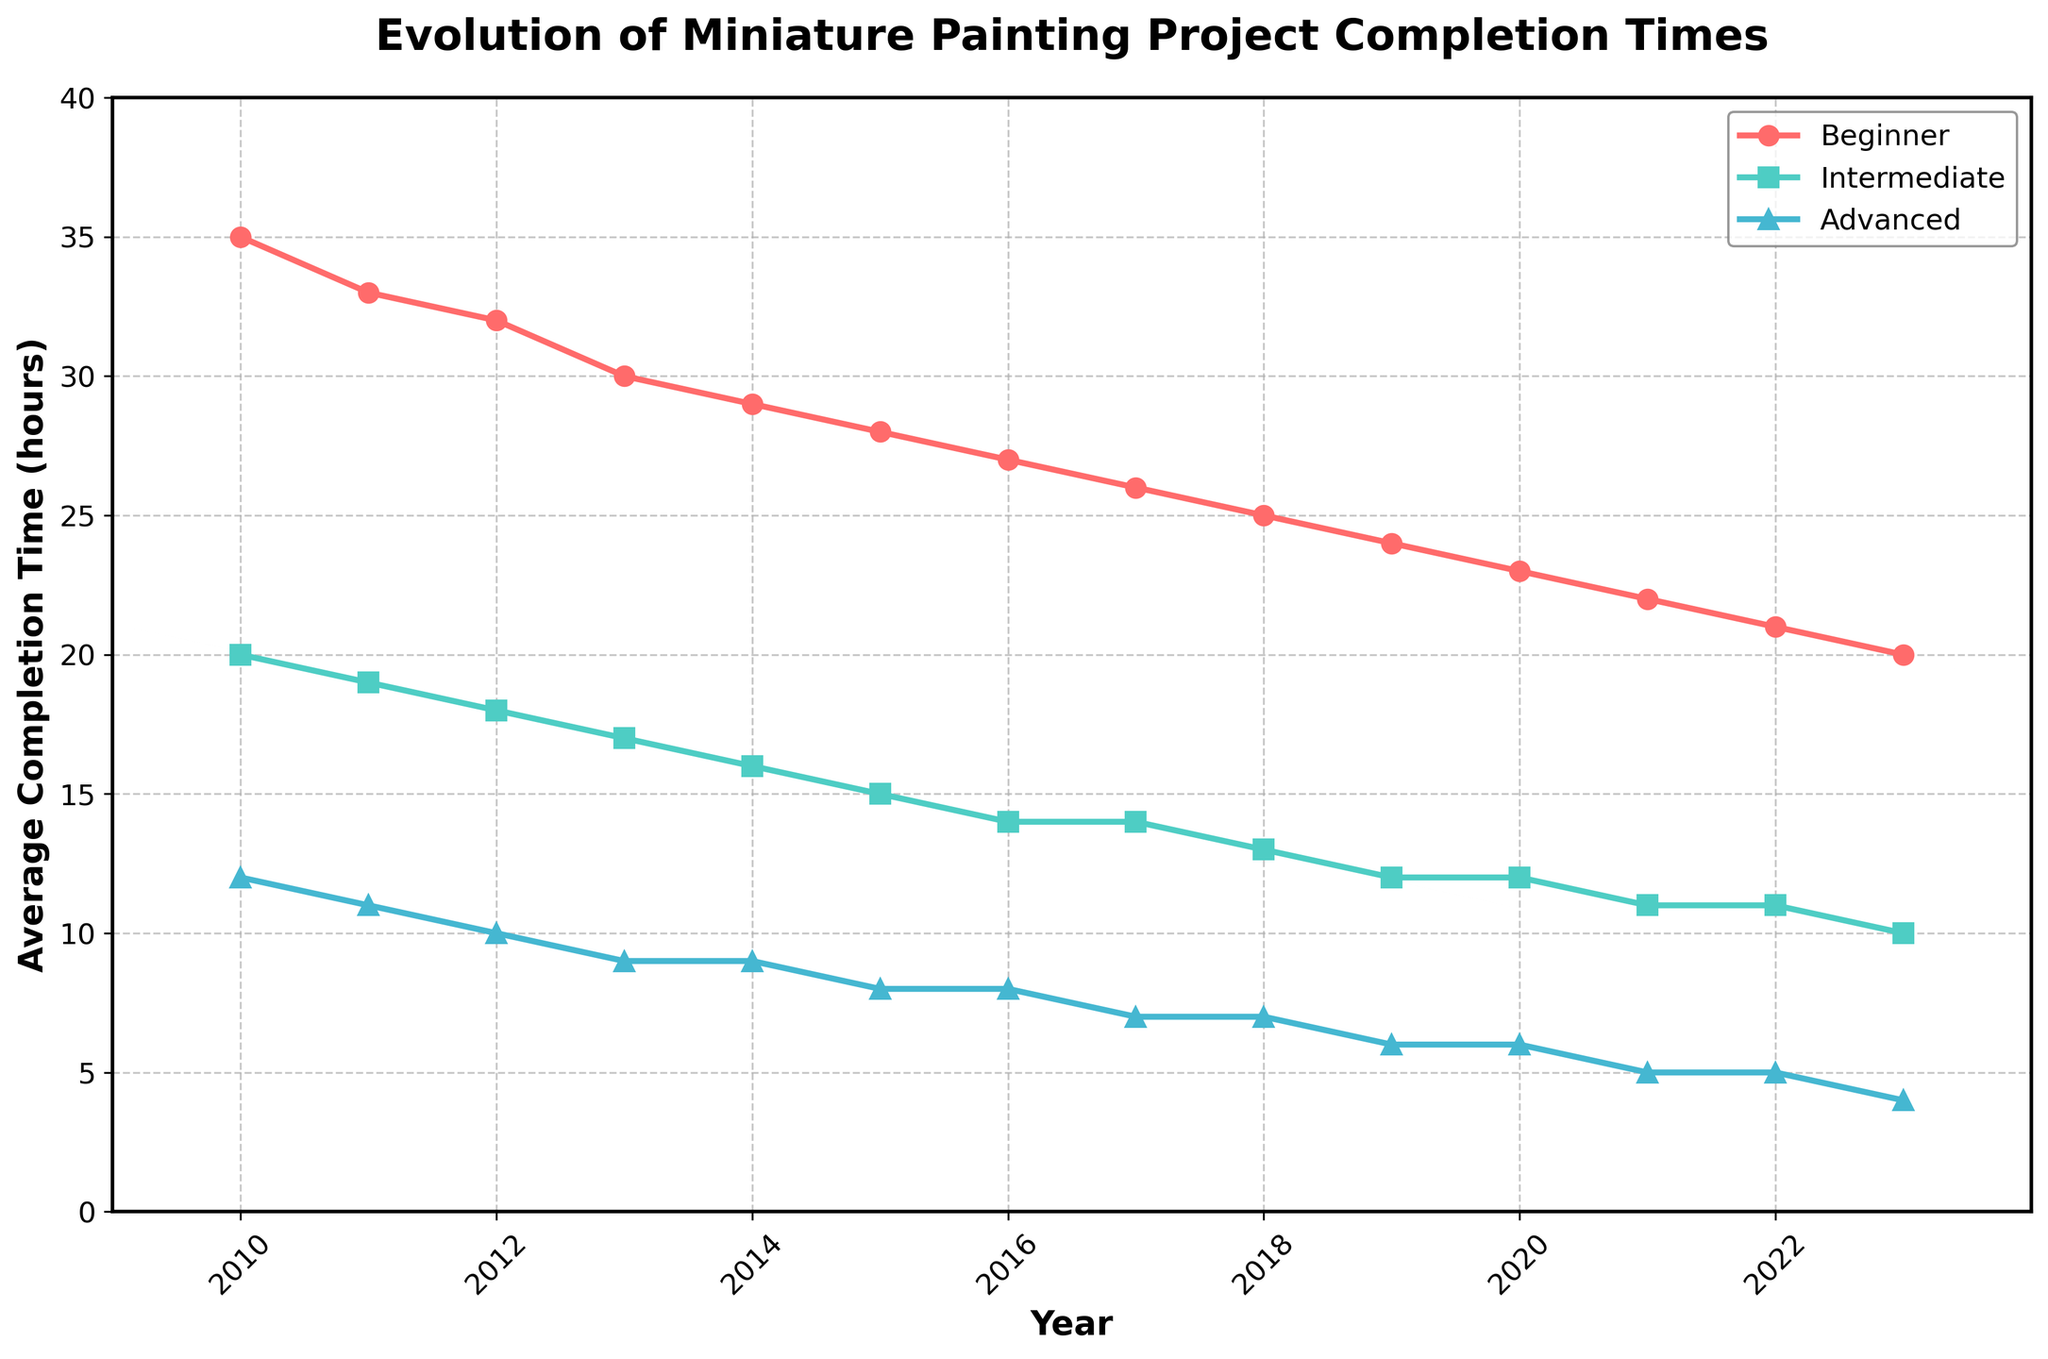What year shows the lowest average completion time for advanced painters? Looking at the blue line representing advanced painters, the line reaches its lowest point at 2023.
Answer: 2023 How much did the average completion time for beginners decrease from 2010 to 2023? The average completion time for beginners in 2010 is 35 hours and in 2023 is 20 hours. The difference is 35 - 20 = 15 hours.
Answer: 15 hours Which group had the smallest change in average completion time from 2010 to 2023? The differences in time are:
- Beginners: 35 - 20 = 15 hours
- Intermediate: 20 - 10 = 10 hours
- Advanced: 12 - 4 = 8 hours
Advanced painters had the smallest change of 8 hours.
Answer: Advanced painters What are the average completion times for intermediate painters in 2014 as compared to advanced painters in 2017? The average completion time for intermediate painters in 2014 is 16 hours, and for advanced painters in 2017 it is 7 hours.
Answer: 16 hours (Intermediate 2014), 7 hours (Advanced 2017) Between which two consecutive years did beginner painters see the largest drop in average completion time? By checking the values year by year, the largest drop for beginners is between 2022 and 2023: 21 hours to 20 hours.
Answer: 2022-2023 What is the overall average completion time for advanced painters from 2010 to 2023? The average completion times are [12, 11, 10, 9, 9, 8, 8, 7, 7, 6, 6, 5, 5, 4]. Summing these up gives a total of 107, and dividing by 14 years gives 107/14 ≈ 7.64 hours.
Answer: ~7.64 hours Which group consistently improved their average completion time throughout the years? All groups (Beginners, Intermediate, and Advanced) show a consistent decrease in their average completion times from 2010 to 2023.
Answer: All groups How many years did it take for beginner painters to reduce their average completion time by 10 hours? The average completion time for beginner painters drops from 35 hours in 2010 to 25 hours in 2018. It took 2018-2010 = 8 years.
Answer: 8 years What was the difference in average completion time between beginners and intermediates in 2015? In 2015, the average completion times are 28 hours for beginners and 15 hours for intermediates. The difference is 28 - 15 = 13 hours.
Answer: 13 hours How did the gap between beginners and advanced painters' average completion times change from 2010 to 2023? - In 2010, the gap was 35 (Beginners) - 12 (Advanced) = 23 hours.
- In 2023, the gap was 20 (Beginners) - 4 (Advanced) = 16 hours.
The gap reduced by 23 - 16 = 7 hours over the years.
Answer: Reduced by 7 hours 